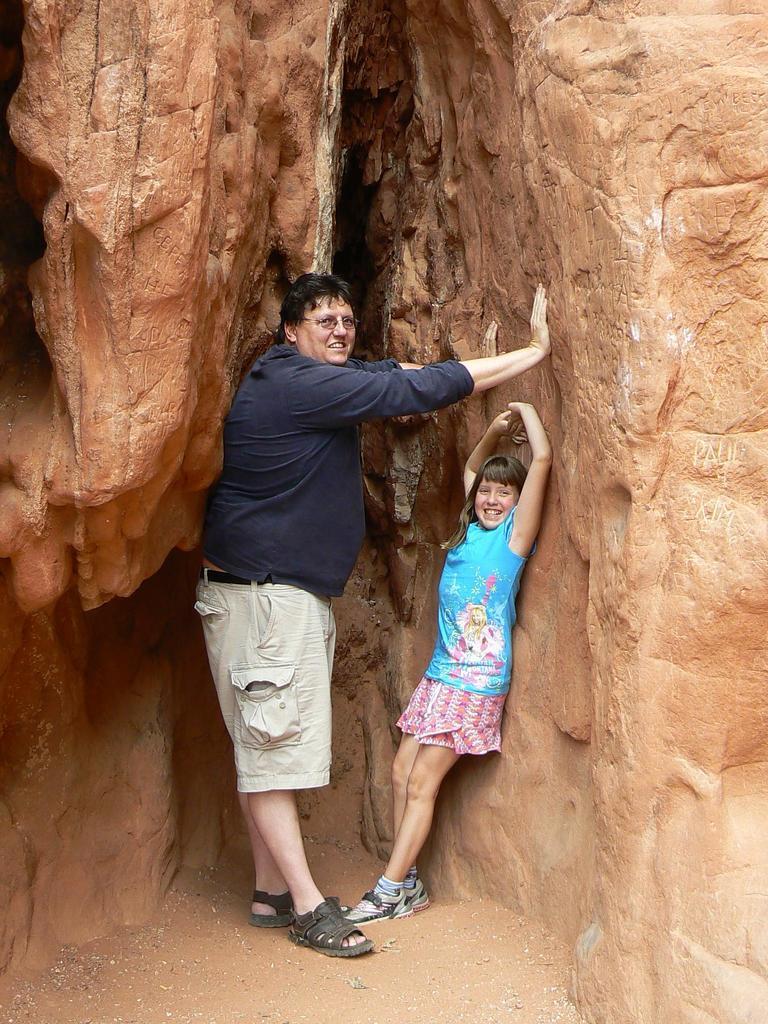How would you summarize this image in a sentence or two? In this image we can see a man and a girl standing and smiling in between the rocks. At the bottom we can see the sand. 